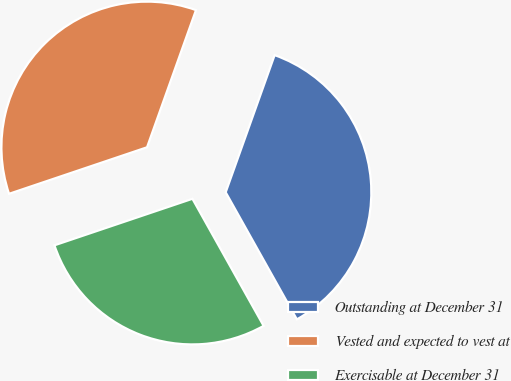<chart> <loc_0><loc_0><loc_500><loc_500><pie_chart><fcel>Outstanding at December 31<fcel>Vested and expected to vest at<fcel>Exercisable at December 31<nl><fcel>36.42%<fcel>35.63%<fcel>27.95%<nl></chart> 